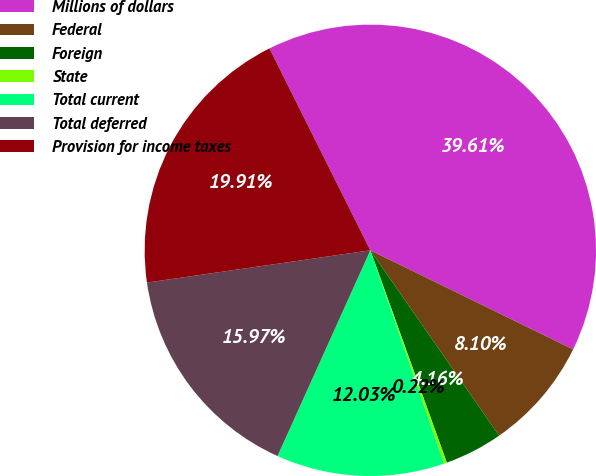Convert chart to OTSL. <chart><loc_0><loc_0><loc_500><loc_500><pie_chart><fcel>Millions of dollars<fcel>Federal<fcel>Foreign<fcel>State<fcel>Total current<fcel>Total deferred<fcel>Provision for income taxes<nl><fcel>39.61%<fcel>8.1%<fcel>4.16%<fcel>0.22%<fcel>12.03%<fcel>15.97%<fcel>19.91%<nl></chart> 